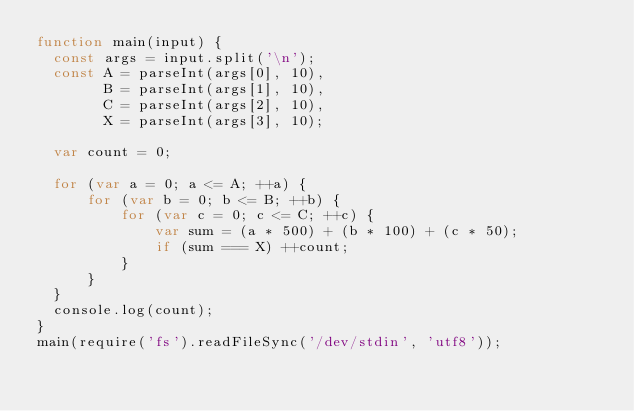<code> <loc_0><loc_0><loc_500><loc_500><_JavaScript_>function main(input) {
  const args = input.split('\n');
  const A = parseInt(args[0], 10),
        B = parseInt(args[1], 10),
        C = parseInt(args[2], 10),
        X = parseInt(args[3], 10);

  var count = 0;

  for (var a = 0; a <= A; ++a) {
      for (var b = 0; b <= B; ++b) {
          for (var c = 0; c <= C; ++c) {
              var sum = (a * 500) + (b * 100) + (c * 50);
              if (sum === X) ++count;
          }
      }
  }
  console.log(count);
}
main(require('fs').readFileSync('/dev/stdin', 'utf8'));</code> 